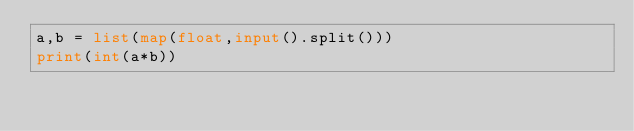Convert code to text. <code><loc_0><loc_0><loc_500><loc_500><_Python_>a,b = list(map(float,input().split()))
print(int(a*b))</code> 